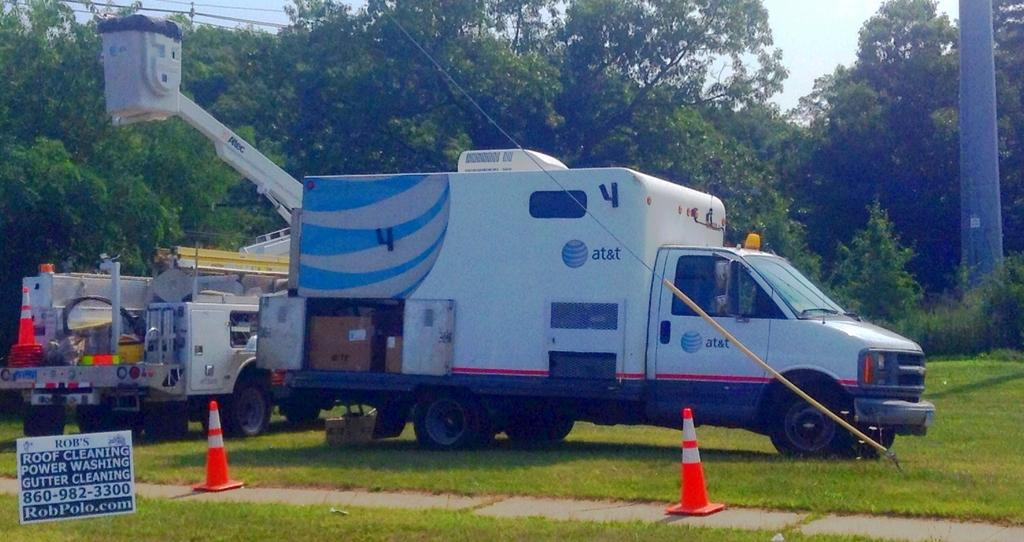<image>
Present a compact description of the photo's key features. A large AT&T bucket truck is on the grass and a sign advertising roof cleaning is nearby. 